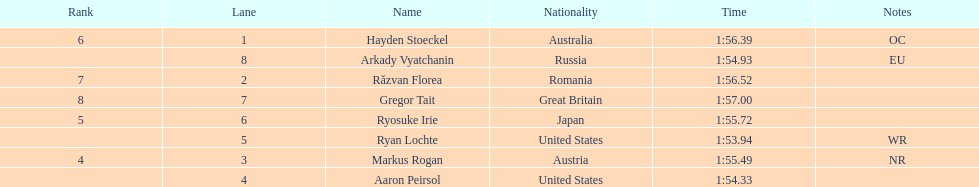Does russia or japan have the longer time? Japan. 